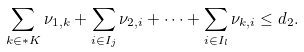Convert formula to latex. <formula><loc_0><loc_0><loc_500><loc_500>\label l { a d d 2 } \sum _ { k \in * K } \nu _ { 1 , k } + \sum _ { i \in I _ { j } } \nu _ { 2 , i } + \dots + \sum _ { i \in I _ { l } } \nu _ { k , i } \leq d _ { 2 } .</formula> 